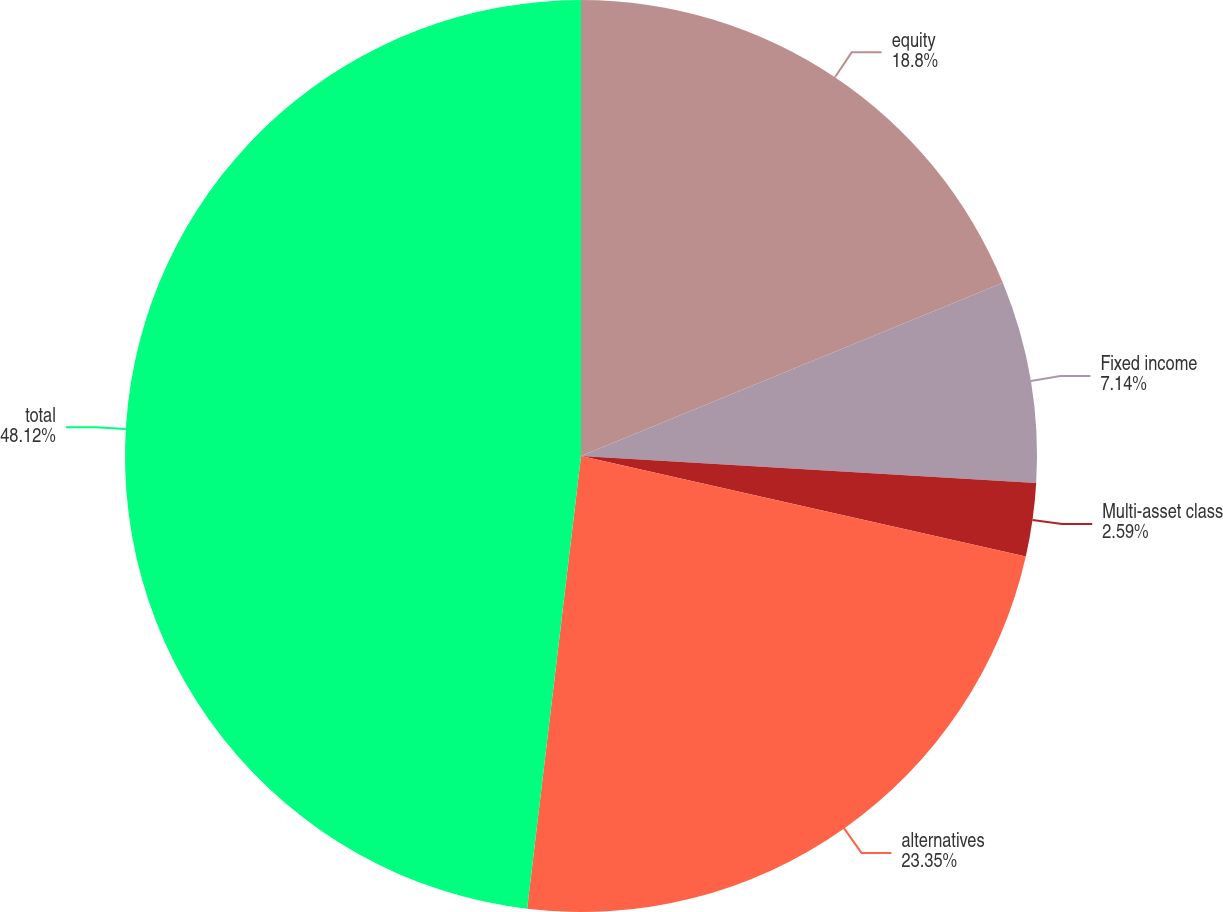<chart> <loc_0><loc_0><loc_500><loc_500><pie_chart><fcel>equity<fcel>Fixed income<fcel>Multi-asset class<fcel>alternatives<fcel>total<nl><fcel>18.8%<fcel>7.14%<fcel>2.59%<fcel>23.35%<fcel>48.11%<nl></chart> 